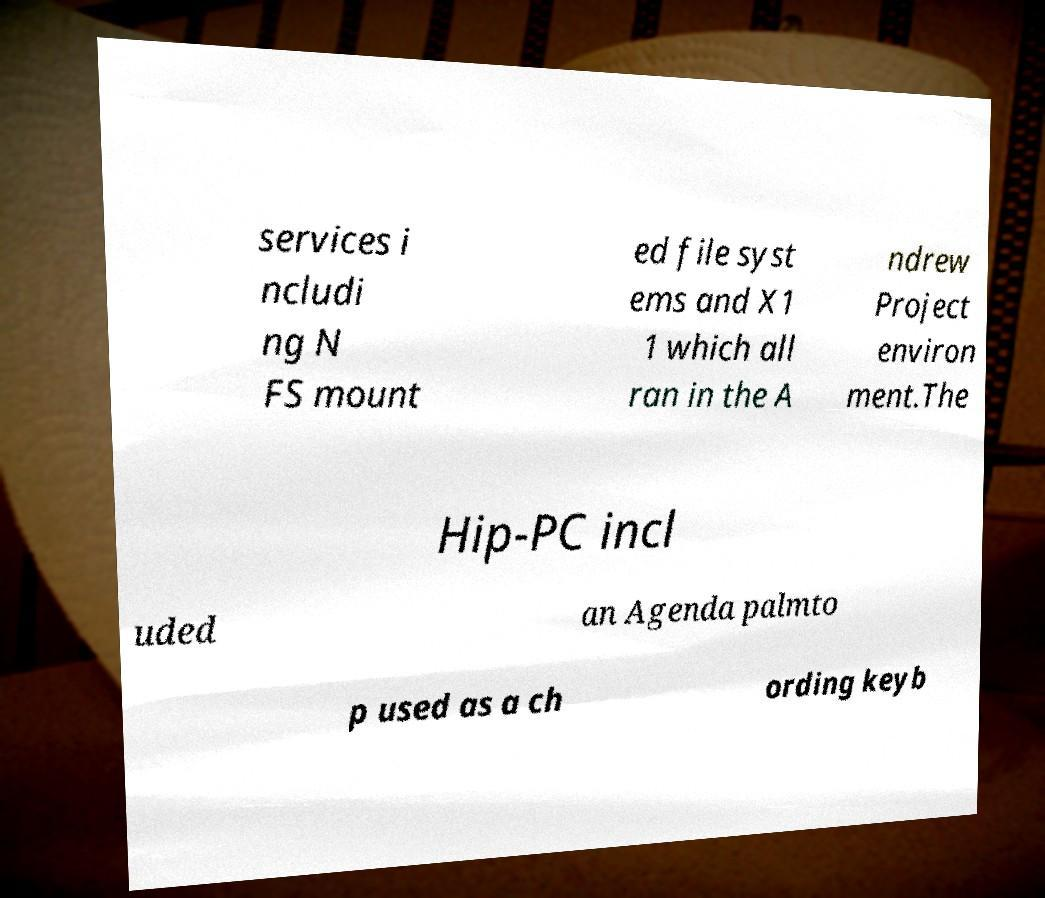Please identify and transcribe the text found in this image. services i ncludi ng N FS mount ed file syst ems and X1 1 which all ran in the A ndrew Project environ ment.The Hip-PC incl uded an Agenda palmto p used as a ch ording keyb 